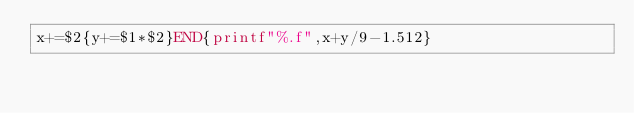<code> <loc_0><loc_0><loc_500><loc_500><_Awk_>x+=$2{y+=$1*$2}END{printf"%.f",x+y/9-1.512}</code> 